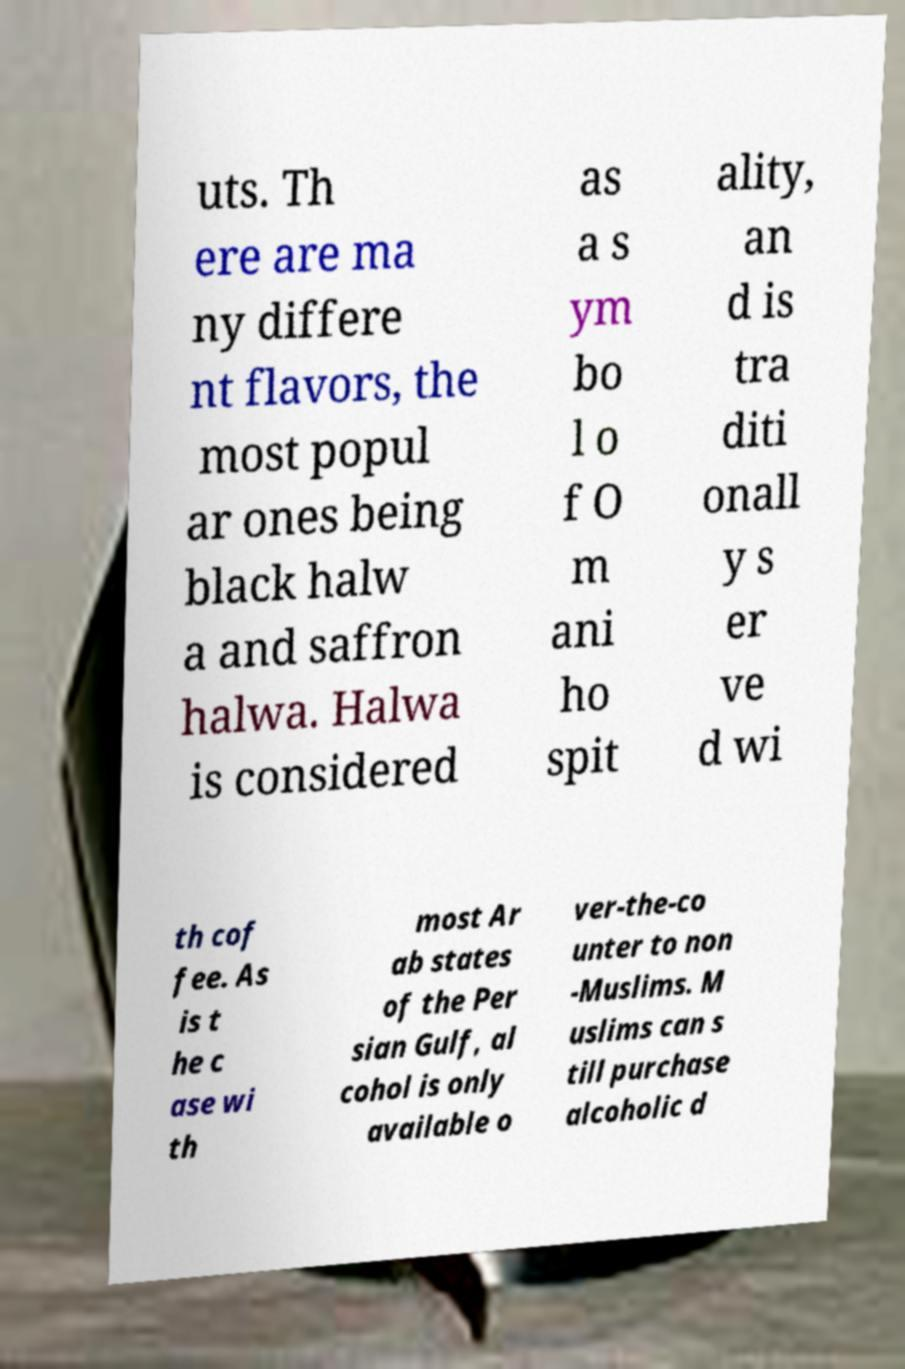Could you extract and type out the text from this image? uts. Th ere are ma ny differe nt flavors, the most popul ar ones being black halw a and saffron halwa. Halwa is considered as a s ym bo l o f O m ani ho spit ality, an d is tra diti onall y s er ve d wi th cof fee. As is t he c ase wi th most Ar ab states of the Per sian Gulf, al cohol is only available o ver-the-co unter to non -Muslims. M uslims can s till purchase alcoholic d 